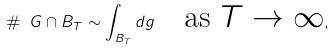Convert formula to latex. <formula><loc_0><loc_0><loc_500><loc_500>\# \ G \cap B _ { T } \sim \int _ { B _ { T } } d g \quad \text {as $T\to \infty$} ,</formula> 